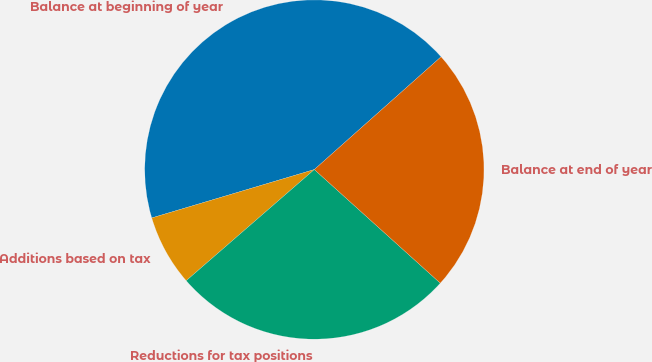Convert chart to OTSL. <chart><loc_0><loc_0><loc_500><loc_500><pie_chart><fcel>Balance at beginning of year<fcel>Additions based on tax<fcel>Reductions for tax positions<fcel>Balance at end of year<nl><fcel>43.03%<fcel>6.77%<fcel>26.94%<fcel>23.25%<nl></chart> 